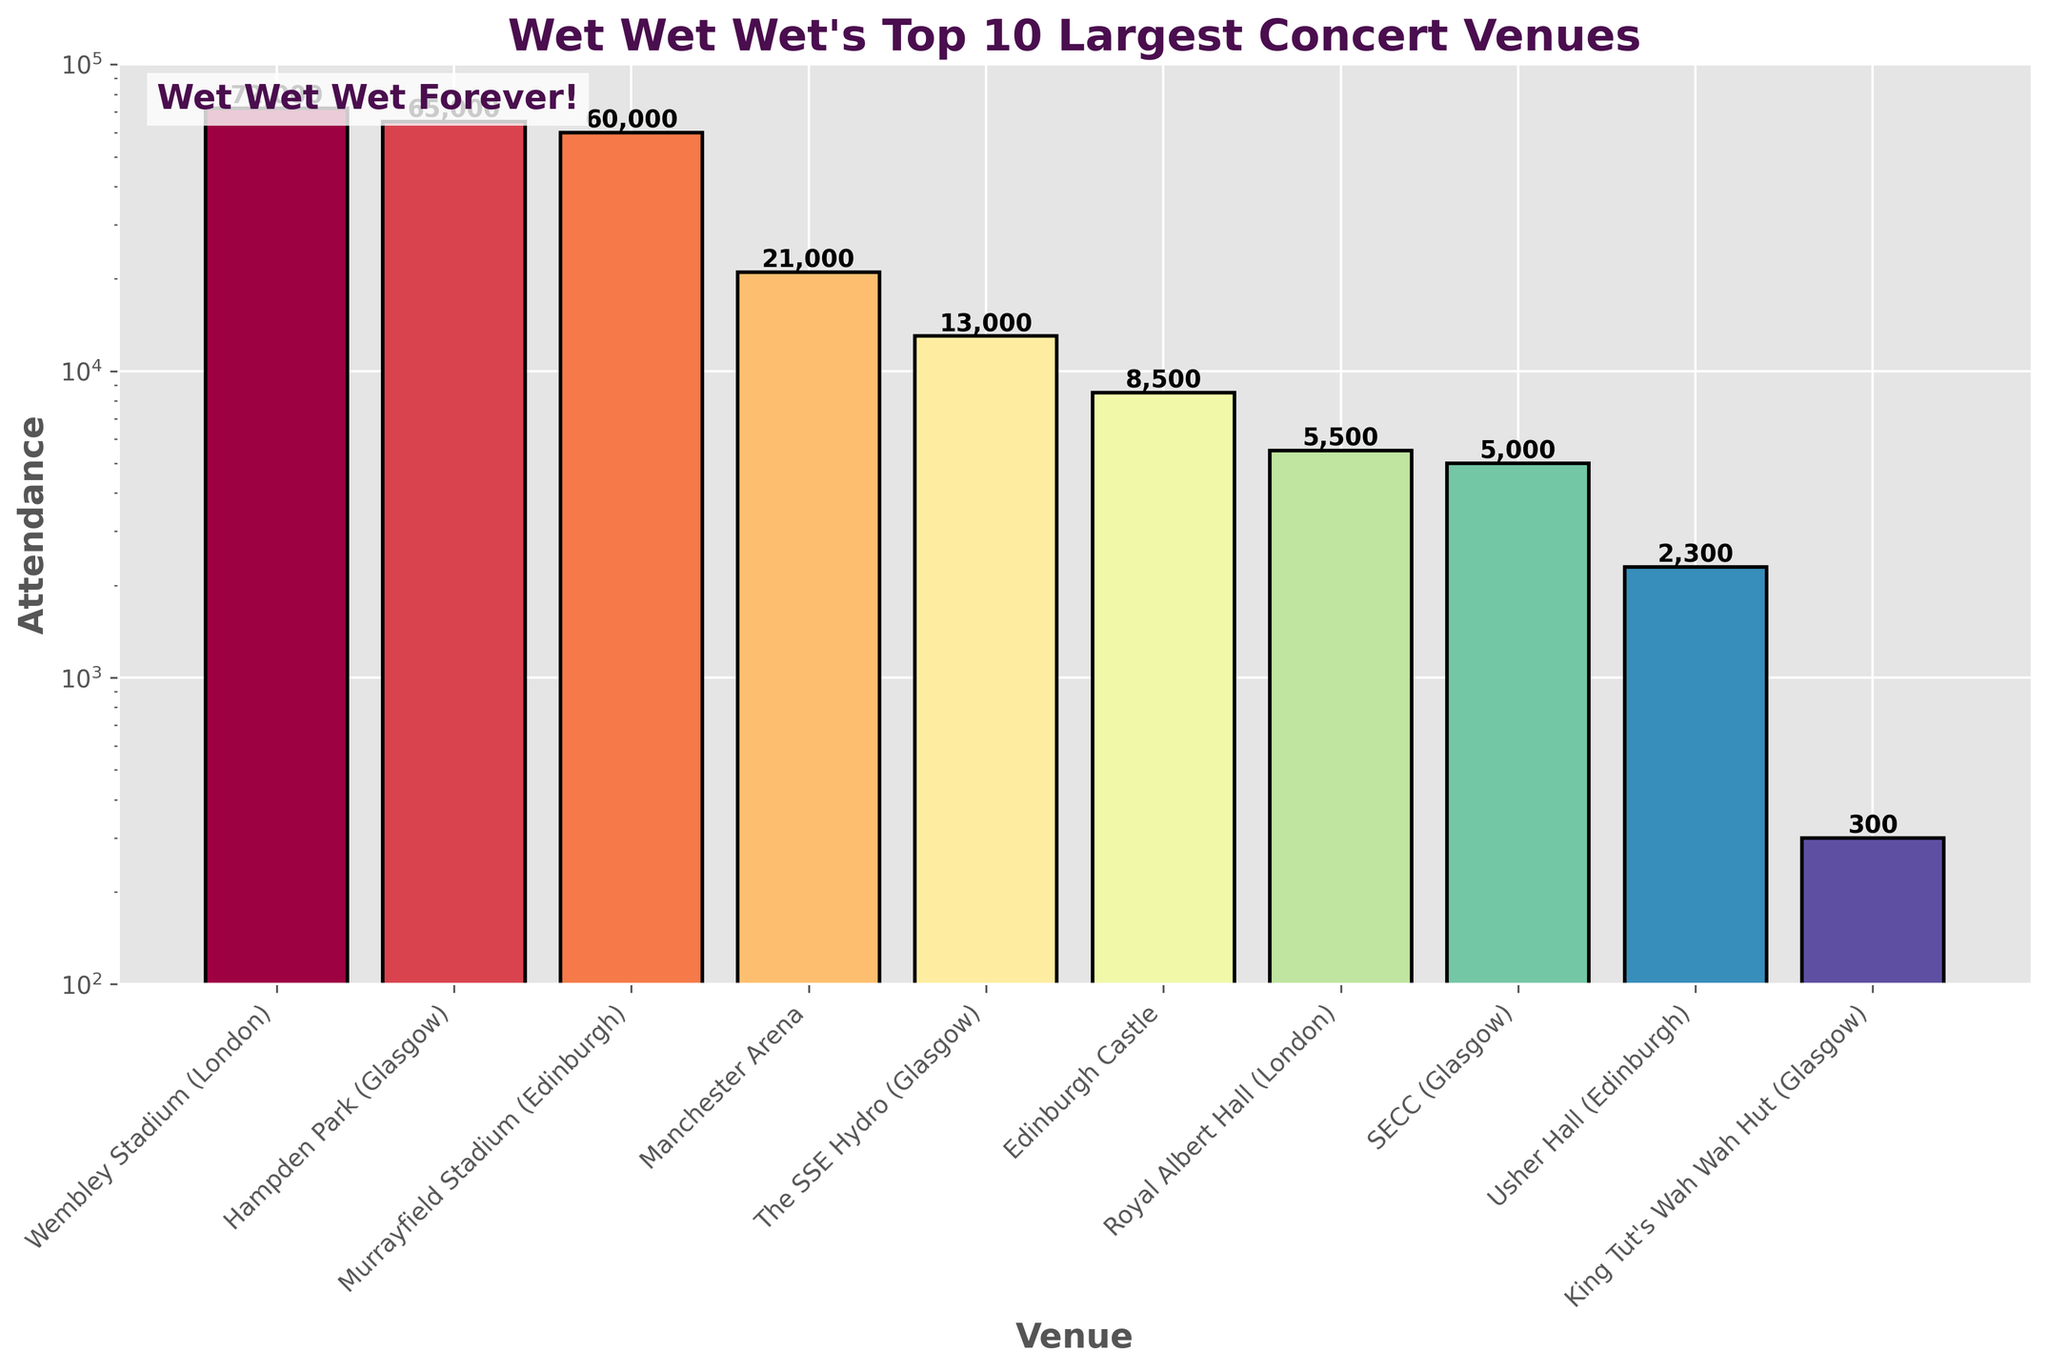What is the venue with the highest attendance? The venue with the highest attendance is identified by the tallest bar. The bar representing Wembley Stadium (London) is the tallest with an attendance number of 72,000.
Answer: Wembley Stadium (London) How many people attended concerts in Glasgow venues combined? To find the combined attendance for Glasgow venues, add the attendance figures for Hampden Park (65,000), The SSE Hydro (13,000), SECC (5,000), and King Tut's Wah Wah Hut (300). This sum is: 65,000 + 13,000 + 5,000 + 300 = 83,300.
Answer: 83,300 Is the attendance at Edinburgh Castle greater than the attendance at The SSE Hydro? Compare the heights of the bars for Edinburgh Castle and The SSE Hydro. The attendance at Edinburgh Castle is 8,500, while the attendance at The SSE Hydro is 13,000. 8,500 is less than 13,000.
Answer: No Compare the attendance at Murrayfield Stadium with Manchester Arena. Which venue had a higher attendance? The bar for Murrayfield Stadium shows an attendance of 60,000 while the bar for Manchester Arena shows an attendance of 21,000. Comparing these numbers, Murrayfield Stadium has a higher attendance.
Answer: Murrayfield Stadium What is the total attendance for the top three venues? Add the attendance numbers for the top three venues: Wembley Stadium (72,000), Hampden Park (65,000), and Murrayfield Stadium (60,000). The total is 72,000 + 65,000 + 60,000 = 197,000.
Answer: 197,000 How does the attendance at Edinburgh Castle compare to Usher Hall and King Tut's Wah Wah Hut combined? Add the attendance for Usher Hall (2,300) and King Tut's Wah Wah Hut (300), which equals 2,600. Compare this to the 8,500 attendance at Edinburgh Castle, with 8,500 being greater than 2,600.
Answer: Greater Which venue had the smallest attendance, and what was the attendance figure? The smallest attendance figure is represented by the shortest bar in the chart, which is King Tut's Wah Wah Hut (Glasgow) with an attendance of 300.
Answer: King Tut's Wah Wah Hut (Glasgow), 300 What is the range of attendance values across all venues? The range is the difference between the maximum and minimum attendance values. The maximum attendance is 72,000 (Wembley Stadium), and the minimum is 300 (King Tut's Wah Wah Hut). Therefore, the range is 72,000 - 300 = 71,700.
Answer: 71,700 What percentage of the attendance at Wembley Stadium is the attendance at Edinburgh Castle? Divide the attendance at Edinburgh Castle (8,500) by the attendance at Wembley Stadium (72,000) and multiply by 100. (8,500 / 72,000) * 100 = 11.8%.
Answer: 11.8% Identify the venue that had an attendance exactly one-tenth of the attendance at Hampden Park. Calculate one-tenth of Hampden Park's attendance: 65,000 / 10 = 6,500. None of the venues have exactly 6,500; thus, no venue matches this criterion exactly.
Answer: None 